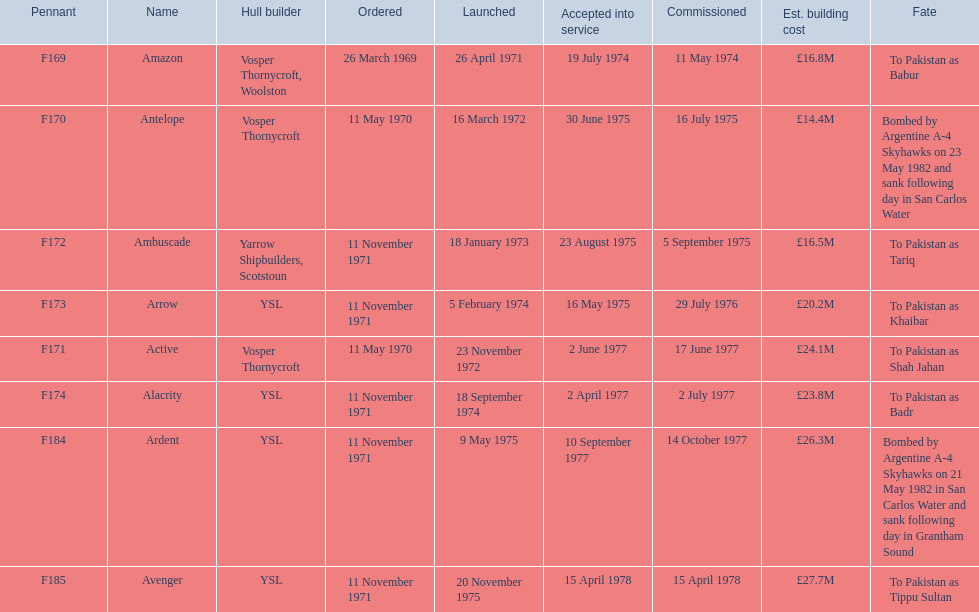What is the last name listed on this chart? Avenger. 